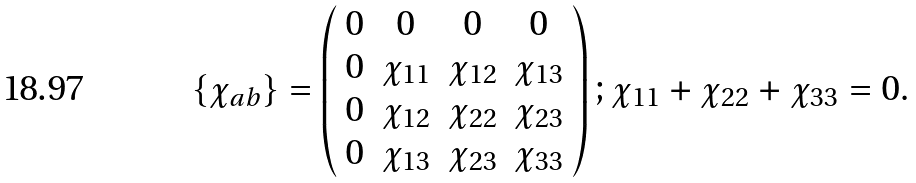Convert formula to latex. <formula><loc_0><loc_0><loc_500><loc_500>\{ \chi _ { a b } \} = \left ( \begin{array} { c c c c } 0 & 0 & 0 & 0 \\ 0 & \chi _ { 1 1 } & \chi _ { 1 2 } & \chi _ { 1 3 } \\ 0 & \chi _ { 1 2 } & \chi _ { 2 2 } & \chi _ { 2 3 } \\ 0 & \chi _ { 1 3 } & \chi _ { 2 3 } & \chi _ { 3 3 } \end{array} \right ) ; \chi _ { 1 1 } + \chi _ { 2 2 } + \chi _ { 3 3 } = 0 .</formula> 